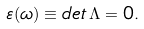Convert formula to latex. <formula><loc_0><loc_0><loc_500><loc_500>\varepsilon ( \omega ) \equiv d e t \, \Lambda = 0 .</formula> 